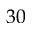<formula> <loc_0><loc_0><loc_500><loc_500>3 0</formula> 